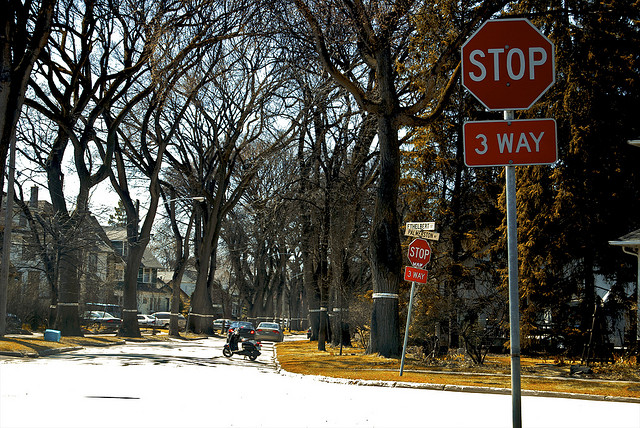Identify the text displayed in this image. STOP WAY 3 STOP 3 